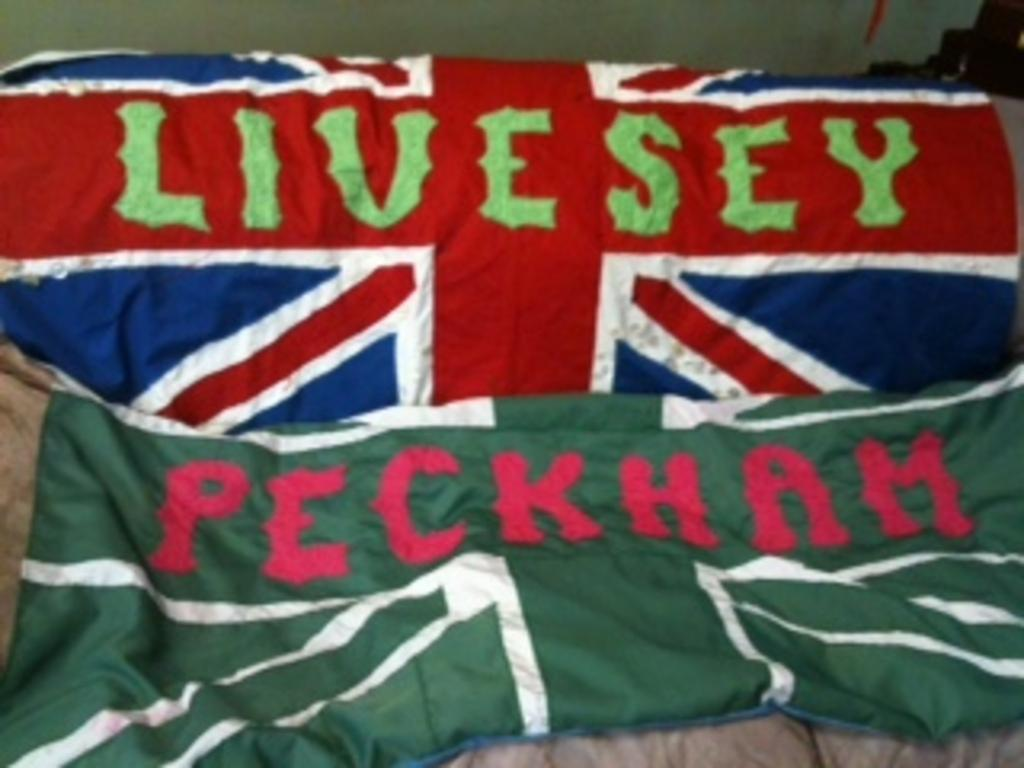What can be seen in the image that represents a country or organization? There are flags in the image. What is written or depicted on the flags? The flags have text on them. What type of stocking can be seen hanging on the flagpole in the image? There is no stocking present in the image; it only features flags with text on them. How many buttons are visible on the flags in the image? There are no buttons visible on the flags in the image. 